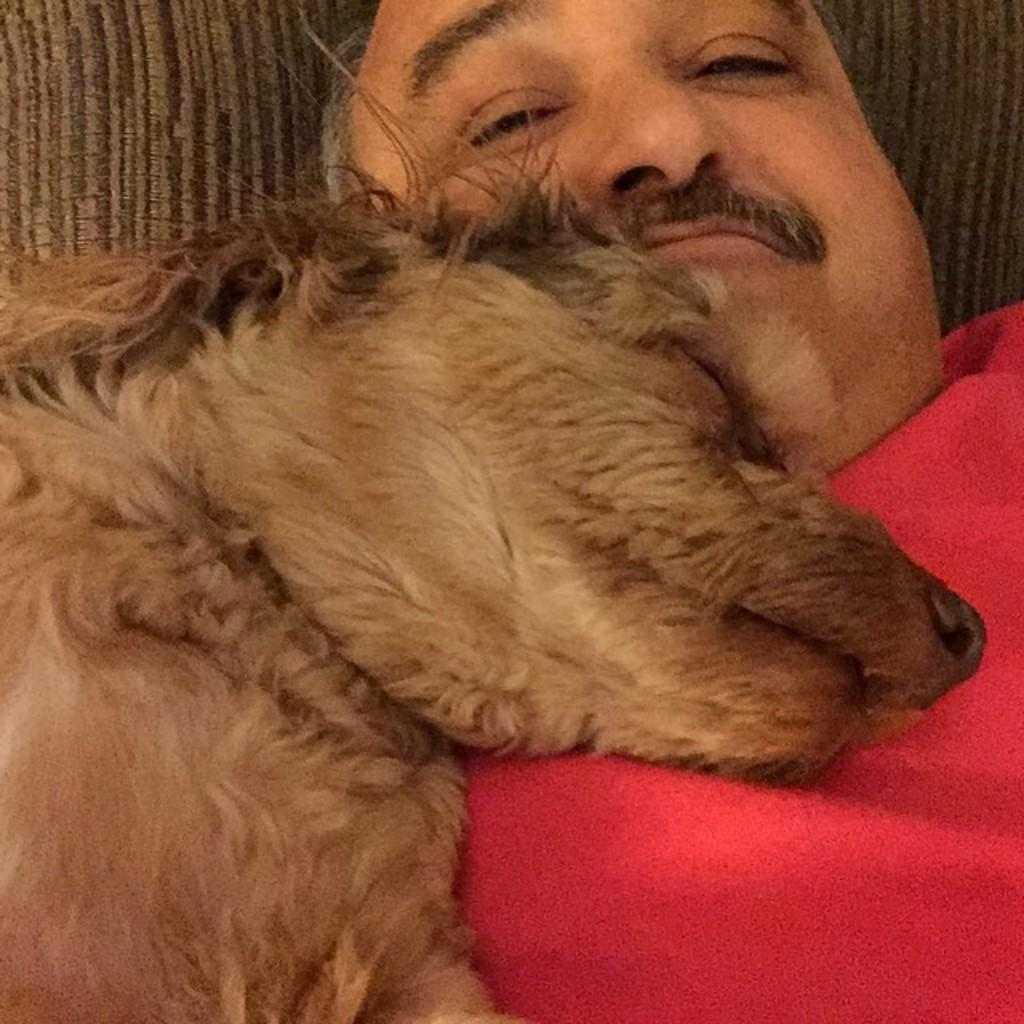Who is present in the image? There is a man in the image. What is the man doing in the image? The man is sleeping. Is there any other living creature in the image? Yes, there is a dog in the image. What is the dog doing in the image? The dog is sleeping on the man. Can you describe the background of the image? The background of the image has a brown color. What religion is the maid practicing in the image? There is no maid present in the image, and therefore no religion can be associated with her. 